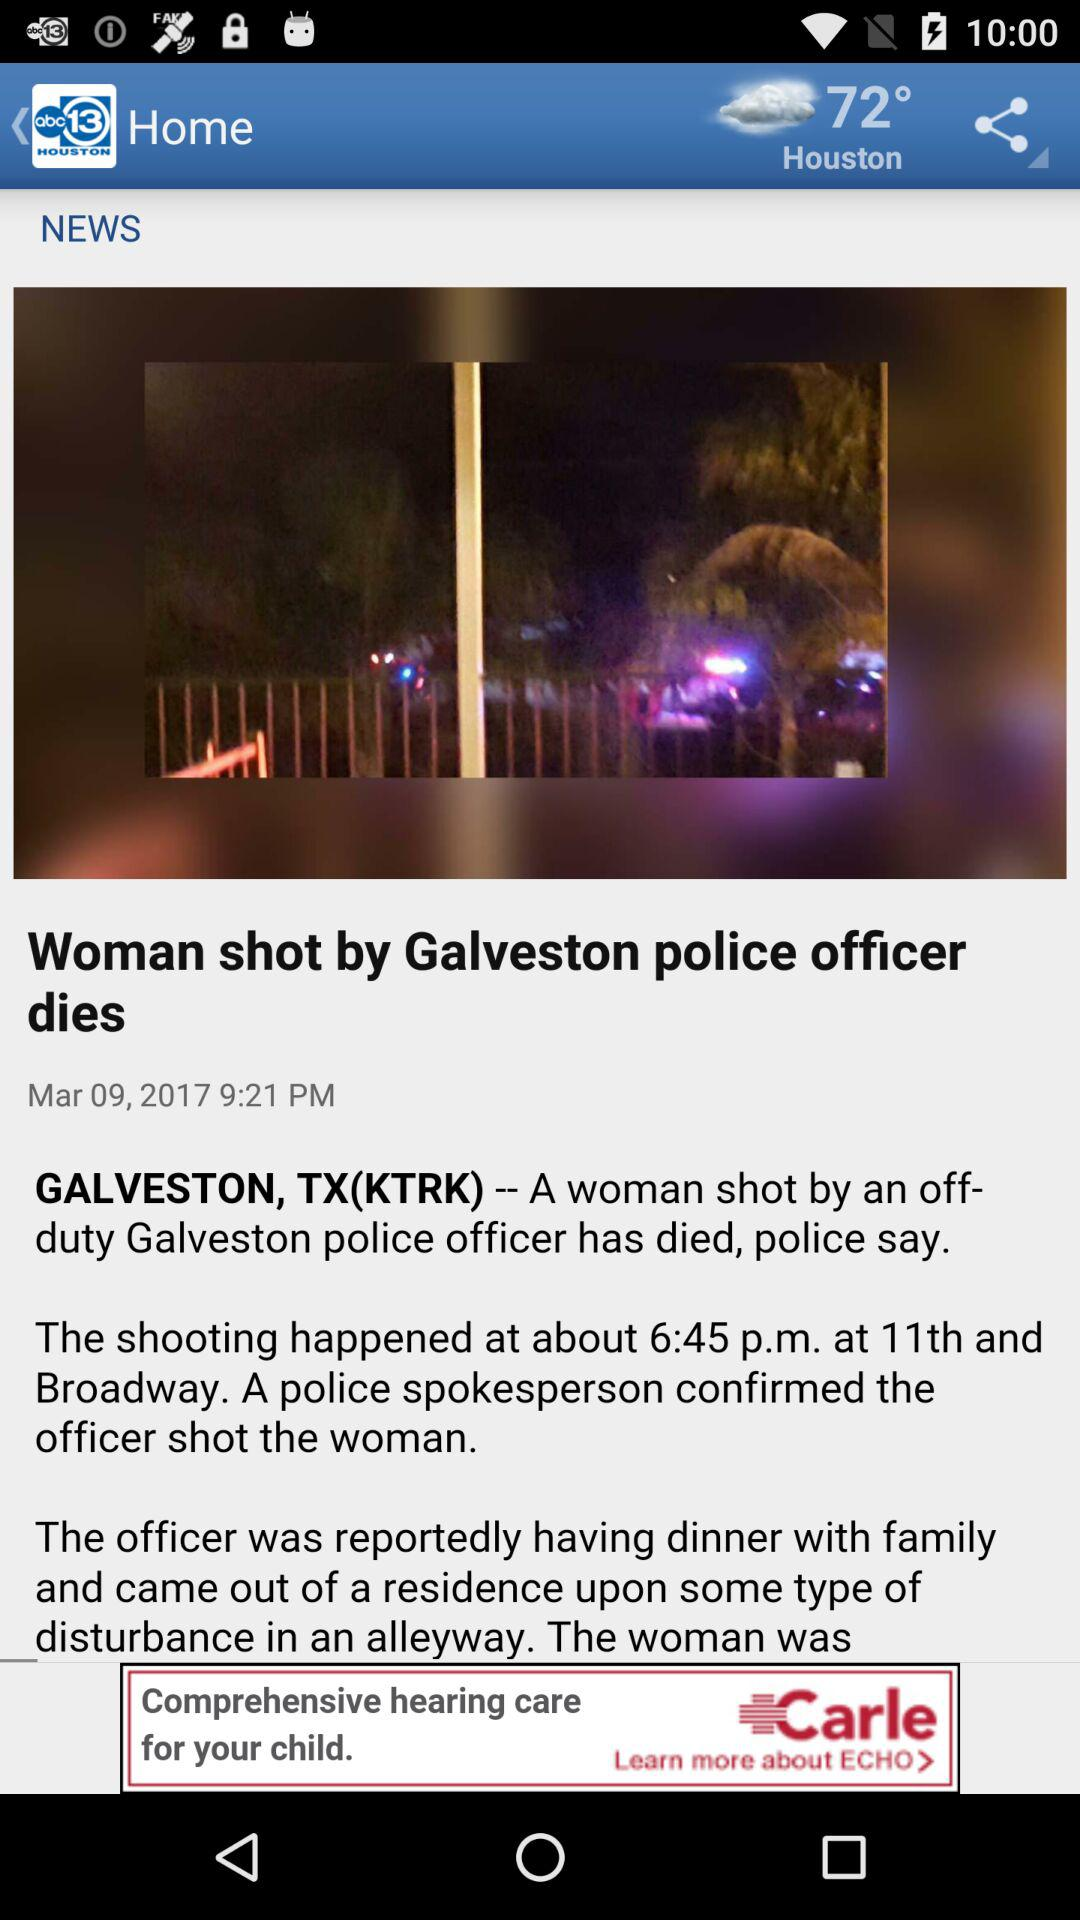When was the news posted? The news was posted on March 9, 2017 at 9:21 PM. 